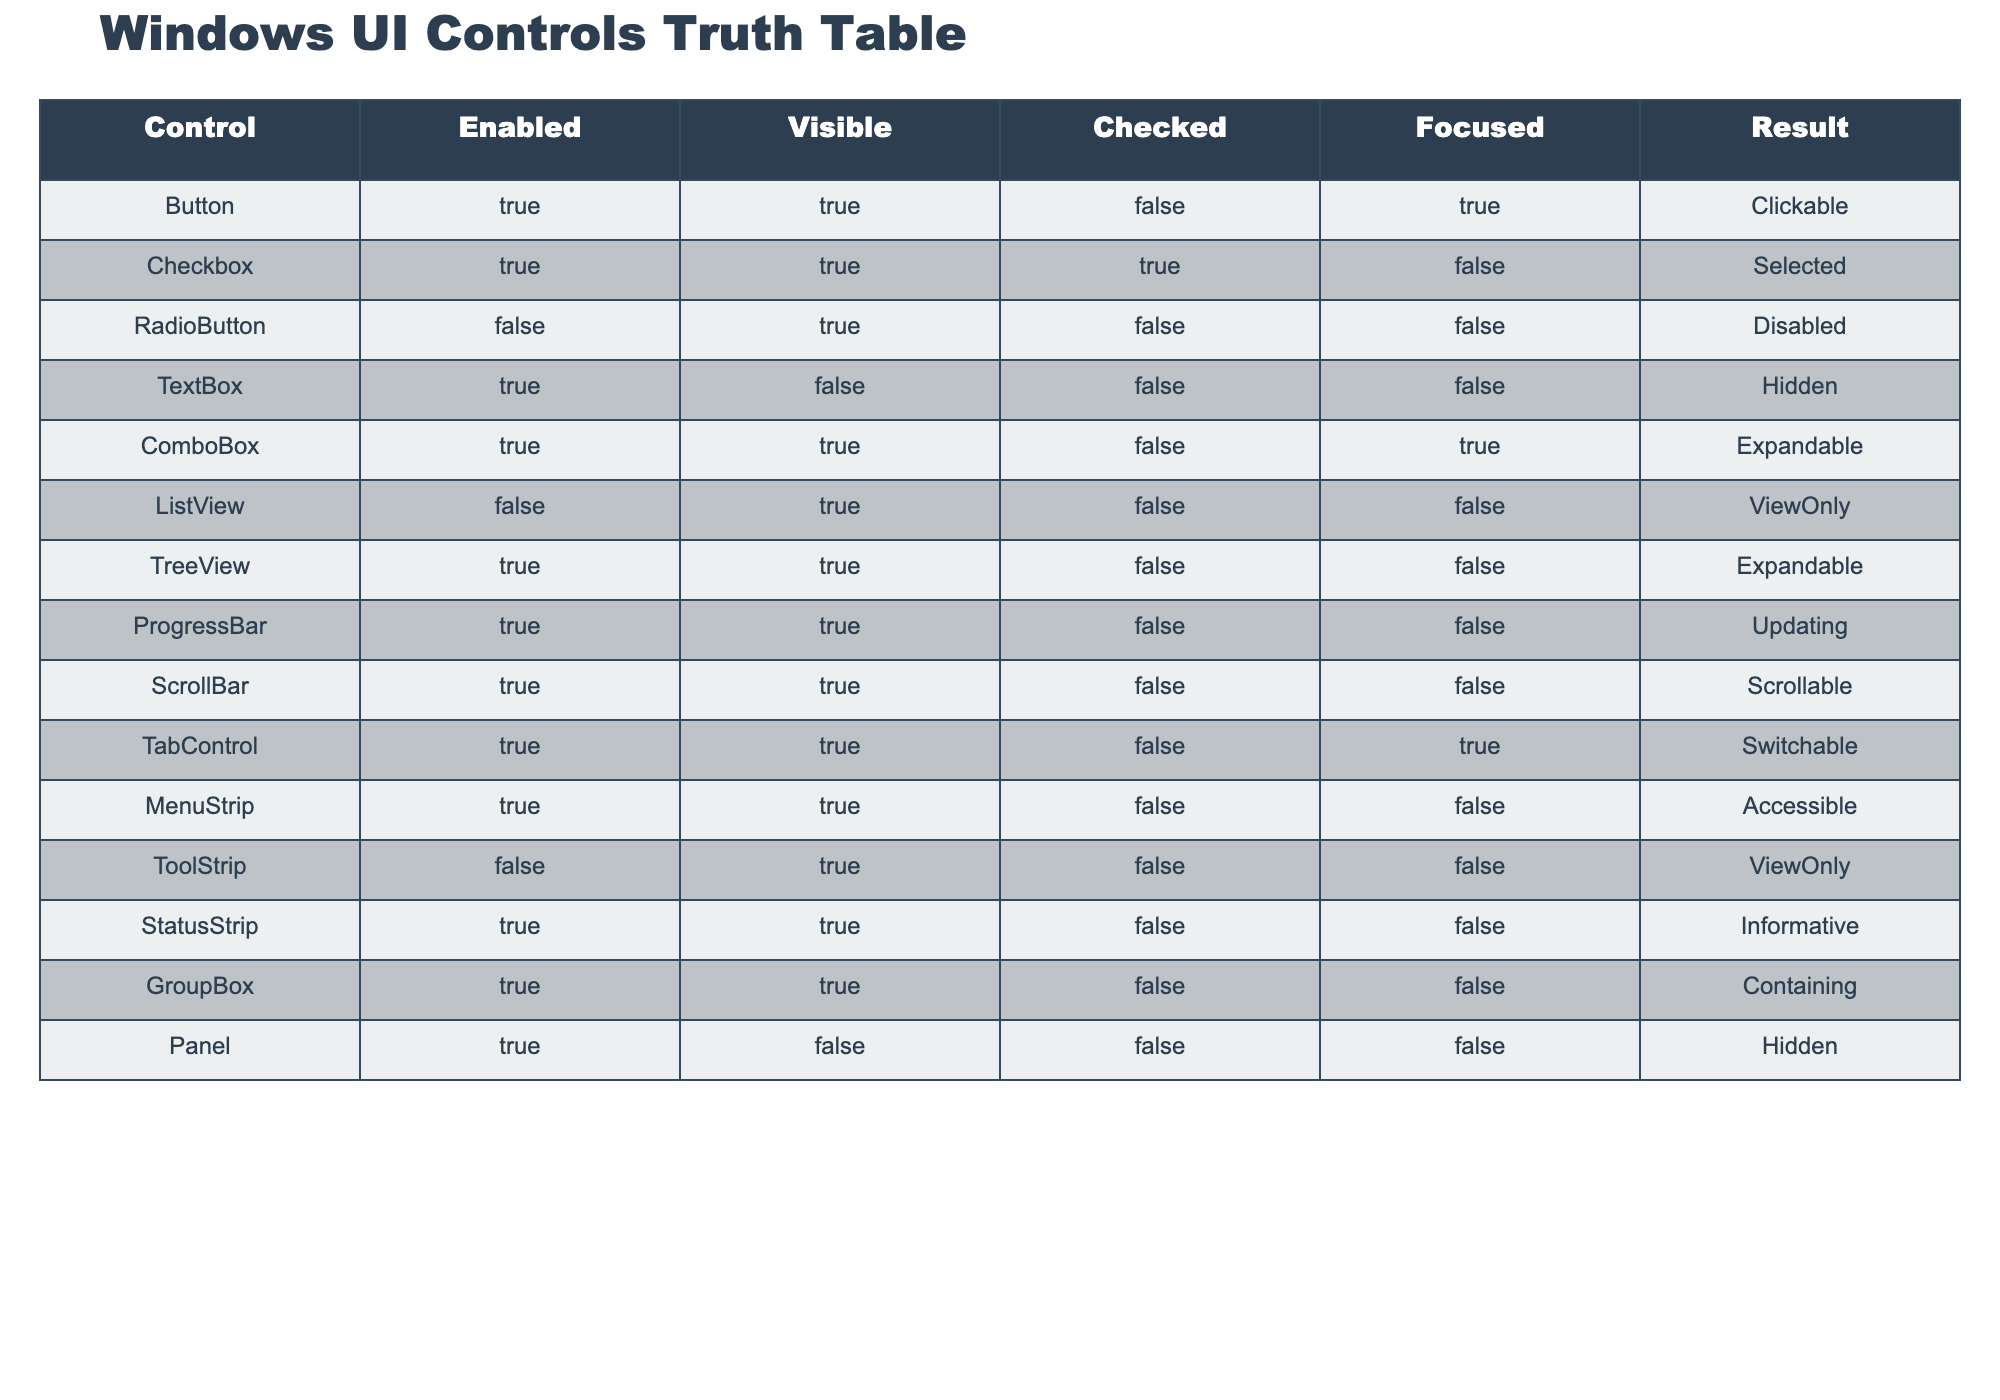What is the result for a Button that is enabled, visible, not checked, and focused? Looking at the table, the row for Button, which has Enabled as TRUE, Visible as TRUE, Checked as FALSE, and Focused as TRUE, shows the Result as Clickable.
Answer: Clickable Is the ComboBox visible? The row for ComboBox shows that the Visible value is TRUE, indicating it is indeed visible.
Answer: Yes How many controls are disabled? Checking the table, there are two controls marked as Disabled: RadioButton and ToolStrip. Thus, we count these two rows.
Answer: 2 What is the result when a ListView is not enabled but is visible and not checked? Referring to the ListView row, the control is marked as Disabled (since Enabled is FALSE), and it results in ViewOnly.
Answer: ViewOnly Are all controls that are checked also enabled? Reviewing the rows, only Checkbox is both Checked (TRUE) and Enabled (TRUE), while the RadioButton is Checked as FALSE. Hence, it is not accurate to say all checked controls are enabled.
Answer: No What results in a control being expandable? The table shows that both ComboBox and TreeView are marked as Expandable. To determine this, they must be Enabled (TRUE) and Visible (TRUE) while Checked and Focused don't necessarily impact this Result.
Answer: ComboBox and TreeView Which control is informative, enabled and visible but not focused? The StatusStrip row indicates it is both Enabled (TRUE) and Visible (TRUE) but has Focused as FALSE, resulting in it being Informative.
Answer: StatusStrip What is the total number of controls that are checked? Examining the rows, only Checkbox has the Checked value as TRUE. Thus, the total number of checked controls is 1.
Answer: 1 Which control provides the result of Hidden? The TextBox row shows Enabled as TRUE, Visible as FALSE, Checked as FALSE, and Focused as FALSE, resulting in Hidden.
Answer: TextBox 